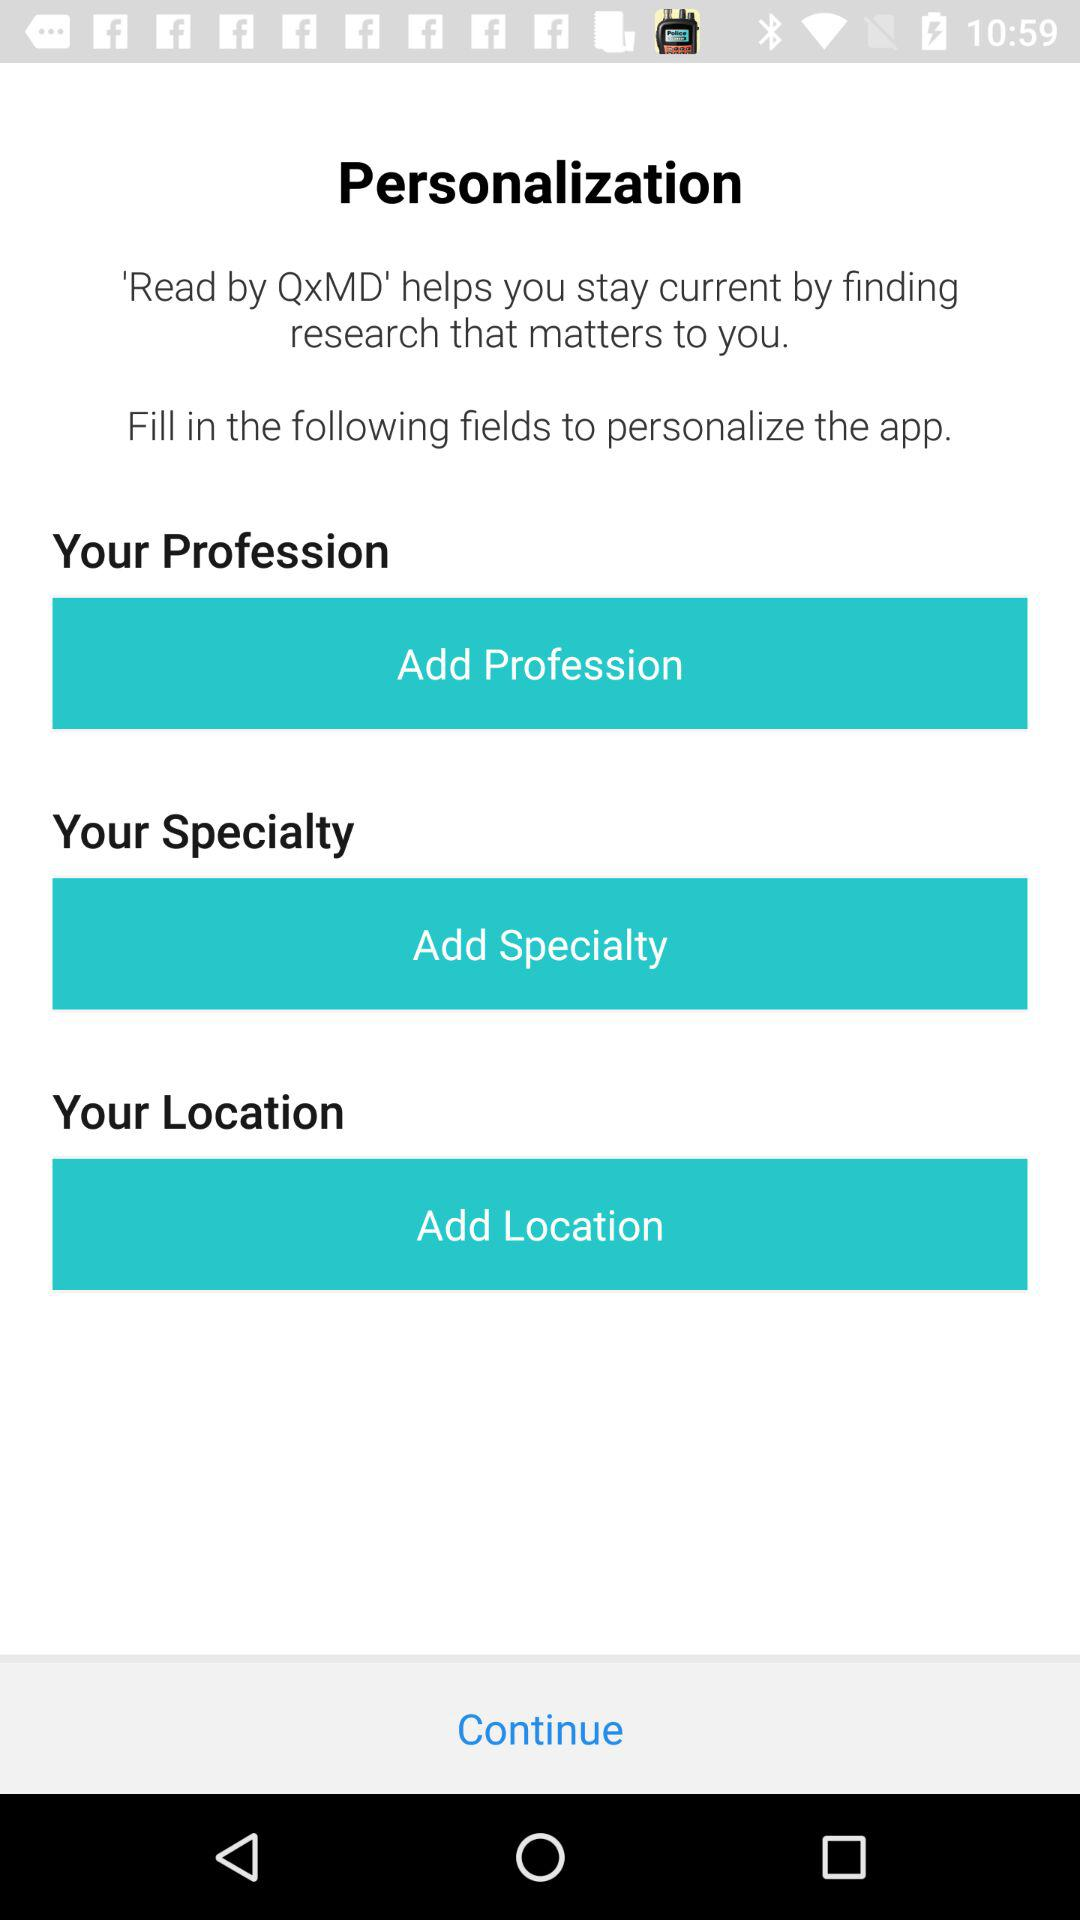Which details are required to help personalize the application? The details required to help personalize the application are profession, specialty and location. 